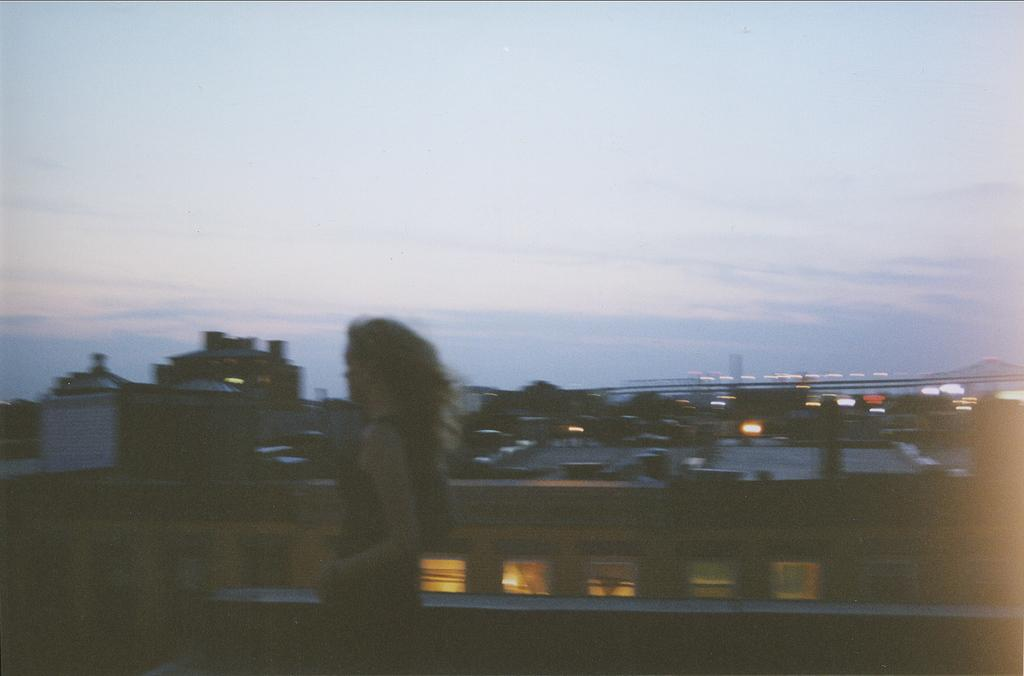What is the main subject of the image? There is a person standing in the image. What can be seen in the background of the image? Buildings, lights, and a bridge are visible in the background. How would you describe the sky in the image? The sky is a combination of white and blue colors. What type of lumber is being used to construct the bridge in the image? There is no visible construction of the bridge in the image, and no information about the type of lumber being used. 